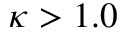Convert formula to latex. <formula><loc_0><loc_0><loc_500><loc_500>\kappa > 1 . 0</formula> 